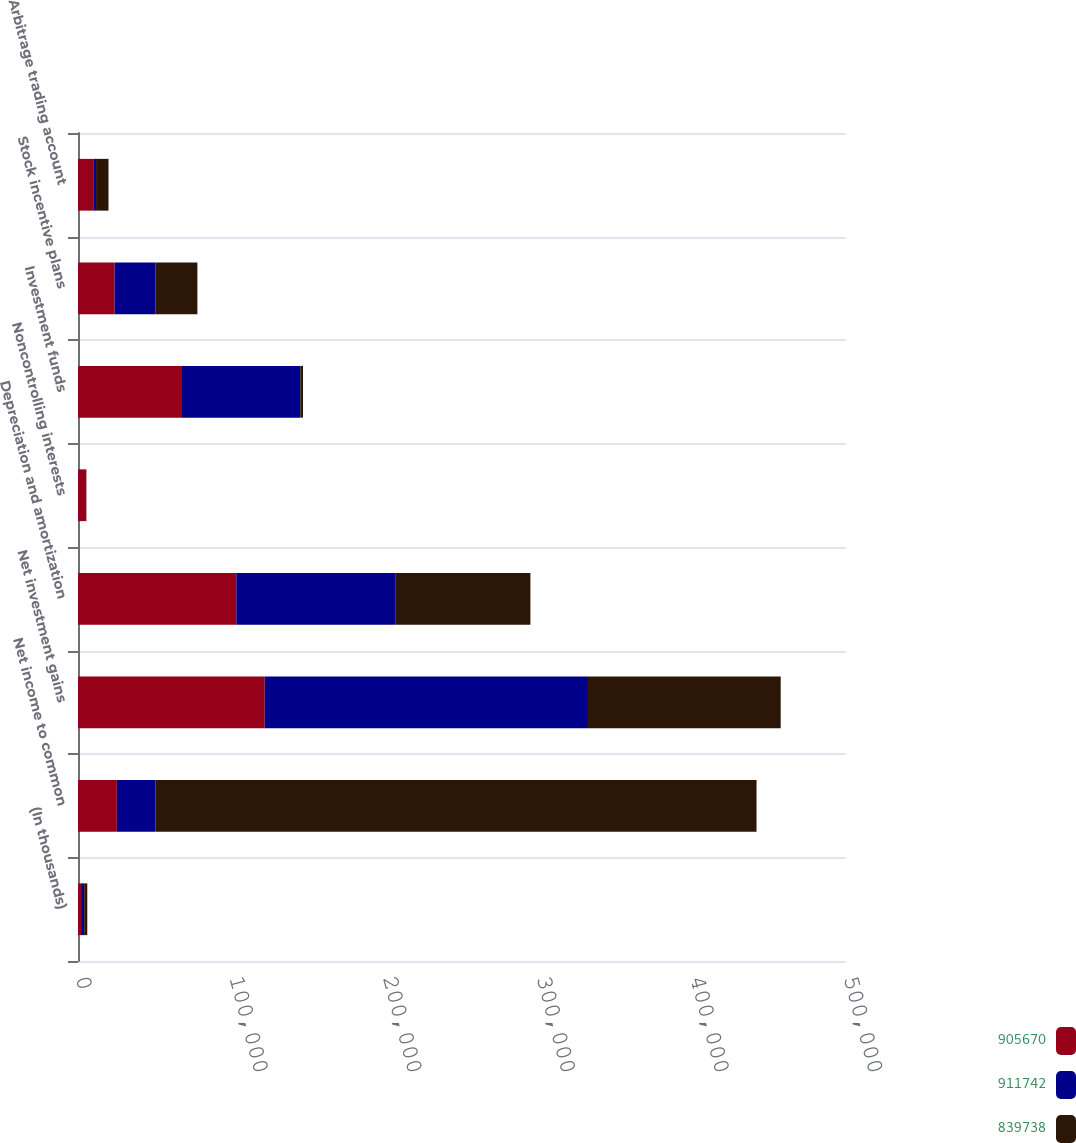Convert chart to OTSL. <chart><loc_0><loc_0><loc_500><loc_500><stacked_bar_chart><ecel><fcel>(In thousands)<fcel>Net income to common<fcel>Net investment gains<fcel>Depreciation and amortization<fcel>Noncontrolling interests<fcel>Investment funds<fcel>Stock incentive plans<fcel>Arbitrage trading account<nl><fcel>905670<fcel>2013<fcel>25273.5<fcel>121544<fcel>103090<fcel>5376<fcel>67712<fcel>23784<fcel>10324<nl><fcel>911742<fcel>2012<fcel>25273.5<fcel>210465<fcel>103419<fcel>51<fcel>77015<fcel>26763<fcel>1424<nl><fcel>839738<fcel>2011<fcel>391211<fcel>125481<fcel>88012<fcel>70<fcel>1751<fcel>27175<fcel>8106<nl></chart> 